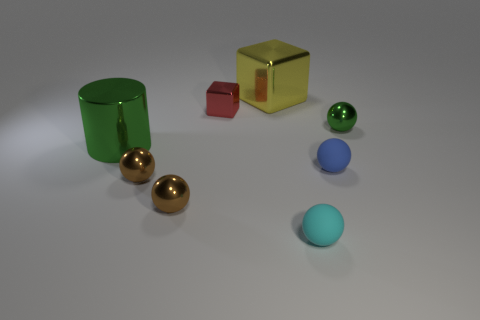Add 1 small red cubes. How many objects exist? 9 Subtract all green balls. How many balls are left? 4 Subtract all green balls. How many balls are left? 4 Subtract 1 cubes. How many cubes are left? 1 Subtract all brown cubes. How many cyan spheres are left? 1 Subtract all red shiny spheres. Subtract all shiny cubes. How many objects are left? 6 Add 8 small cyan rubber balls. How many small cyan rubber balls are left? 9 Add 6 tiny green metallic balls. How many tiny green metallic balls exist? 7 Subtract 1 yellow blocks. How many objects are left? 7 Subtract all balls. How many objects are left? 3 